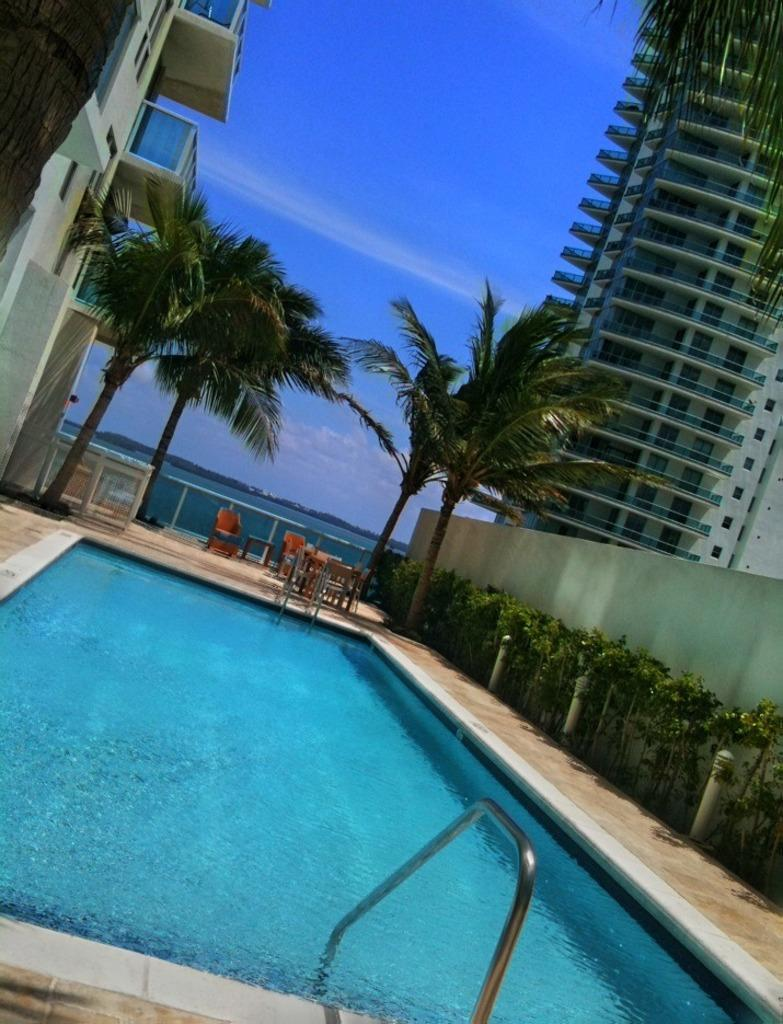What is the main feature in the image? There is a swimming pool in the image. What other elements can be seen in the image? There are plants, trees, poles, chairs, buildings, and water in the background. Can you describe the natural elements in the image? There are plants and trees visible in the image. What is visible in the background of the image? The background of the image includes water and the sky. What type of mailbox can be seen in the image? There is no mailbox present in the image. What sound can be heard coming from the water in the image? There is no sound present in the image, as it is a still image. 